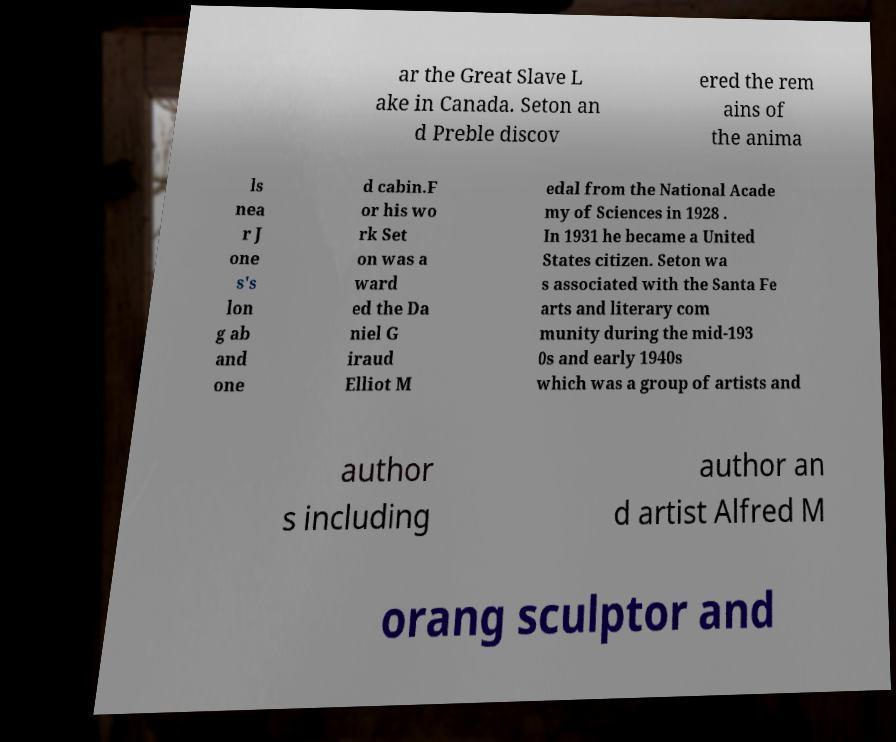Can you accurately transcribe the text from the provided image for me? ar the Great Slave L ake in Canada. Seton an d Preble discov ered the rem ains of the anima ls nea r J one s's lon g ab and one d cabin.F or his wo rk Set on was a ward ed the Da niel G iraud Elliot M edal from the National Acade my of Sciences in 1928 . In 1931 he became a United States citizen. Seton wa s associated with the Santa Fe arts and literary com munity during the mid-193 0s and early 1940s which was a group of artists and author s including author an d artist Alfred M orang sculptor and 